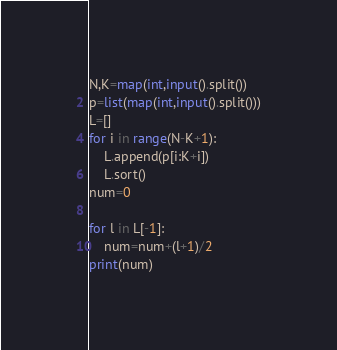Convert code to text. <code><loc_0><loc_0><loc_500><loc_500><_Python_>N,K=map(int,input().split())
p=list(map(int,input().split()))
L=[]
for i in range(N-K+1):
    L.append(p[i:K+i])
    L.sort()
num=0

for l in L[-1]:
    num=num+(l+1)/2
print(num)
</code> 